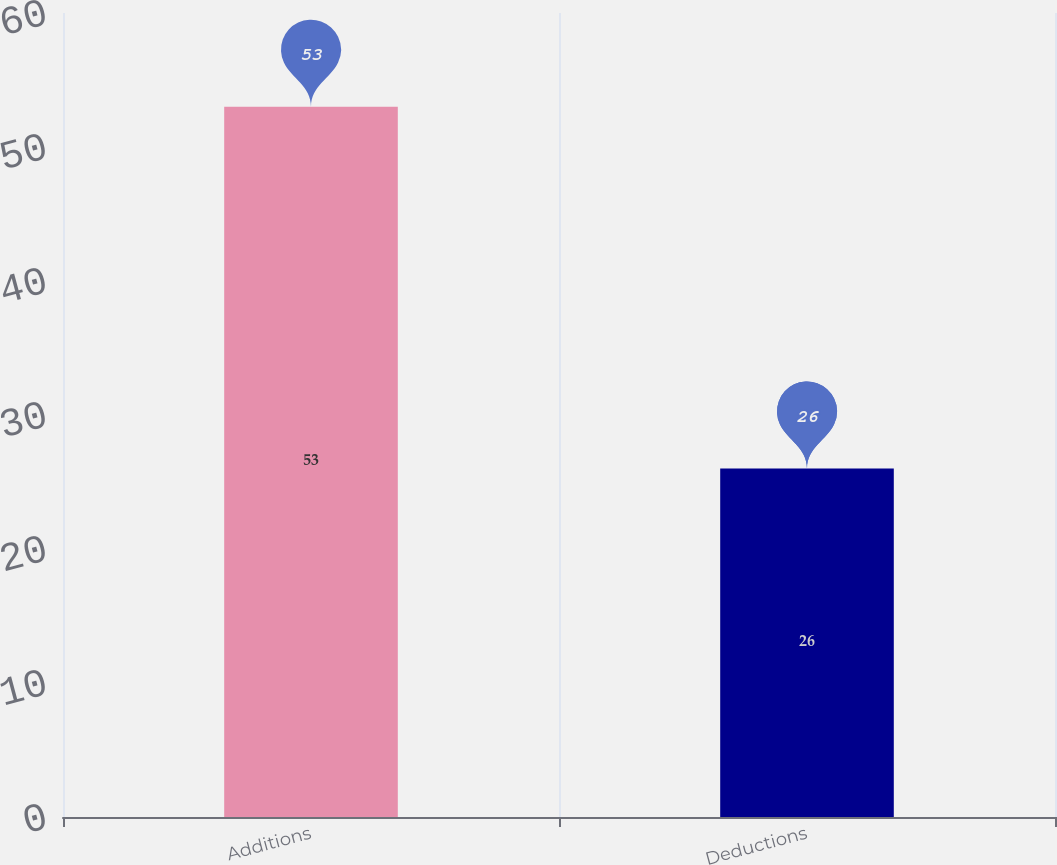Convert chart. <chart><loc_0><loc_0><loc_500><loc_500><bar_chart><fcel>Additions<fcel>Deductions<nl><fcel>53<fcel>26<nl></chart> 